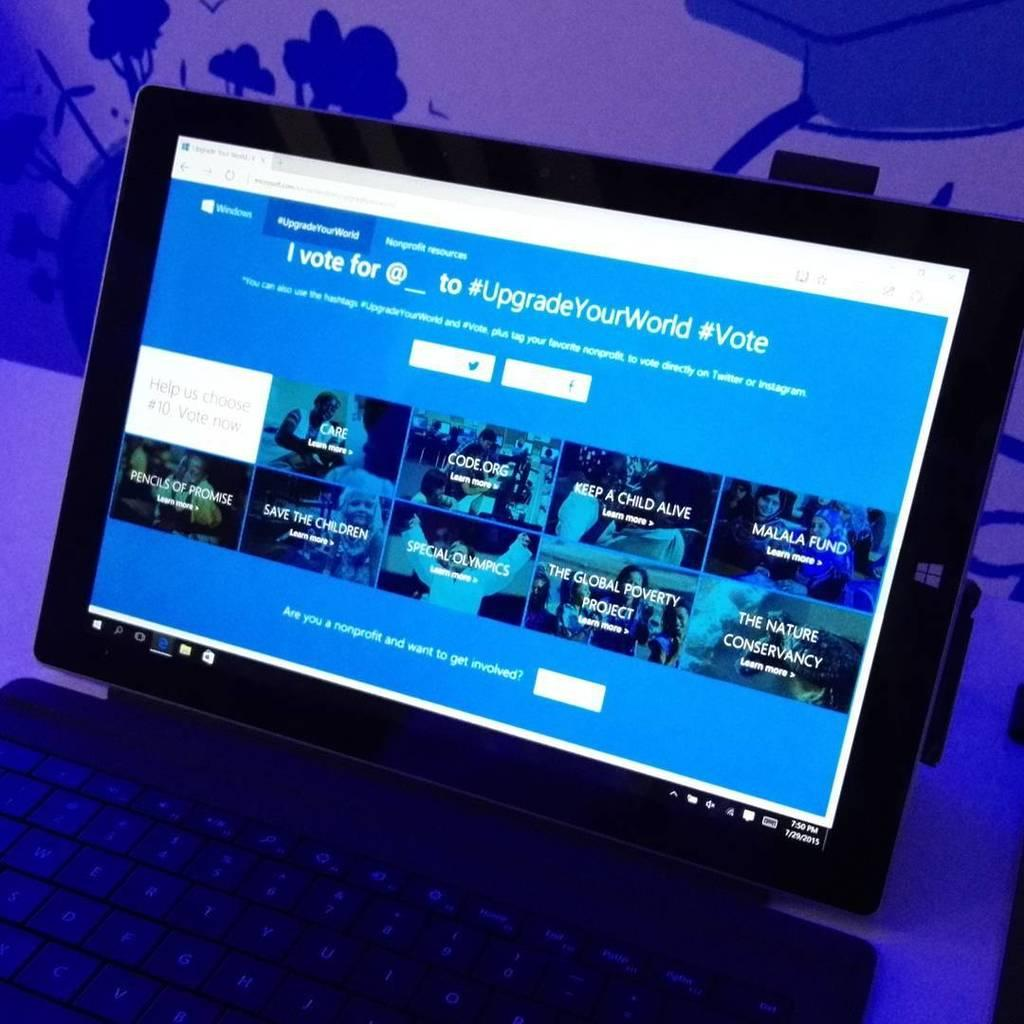<image>
Present a compact description of the photo's key features. A laptop with the monitor opened to a webpage with the hashtag upgradeyourworld. 